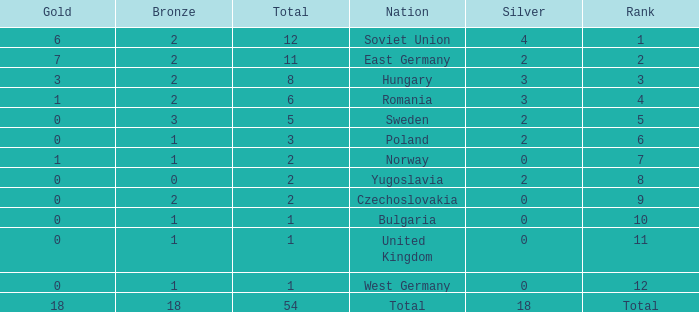What's the total of rank number 6 with more than 2 silver? None. 